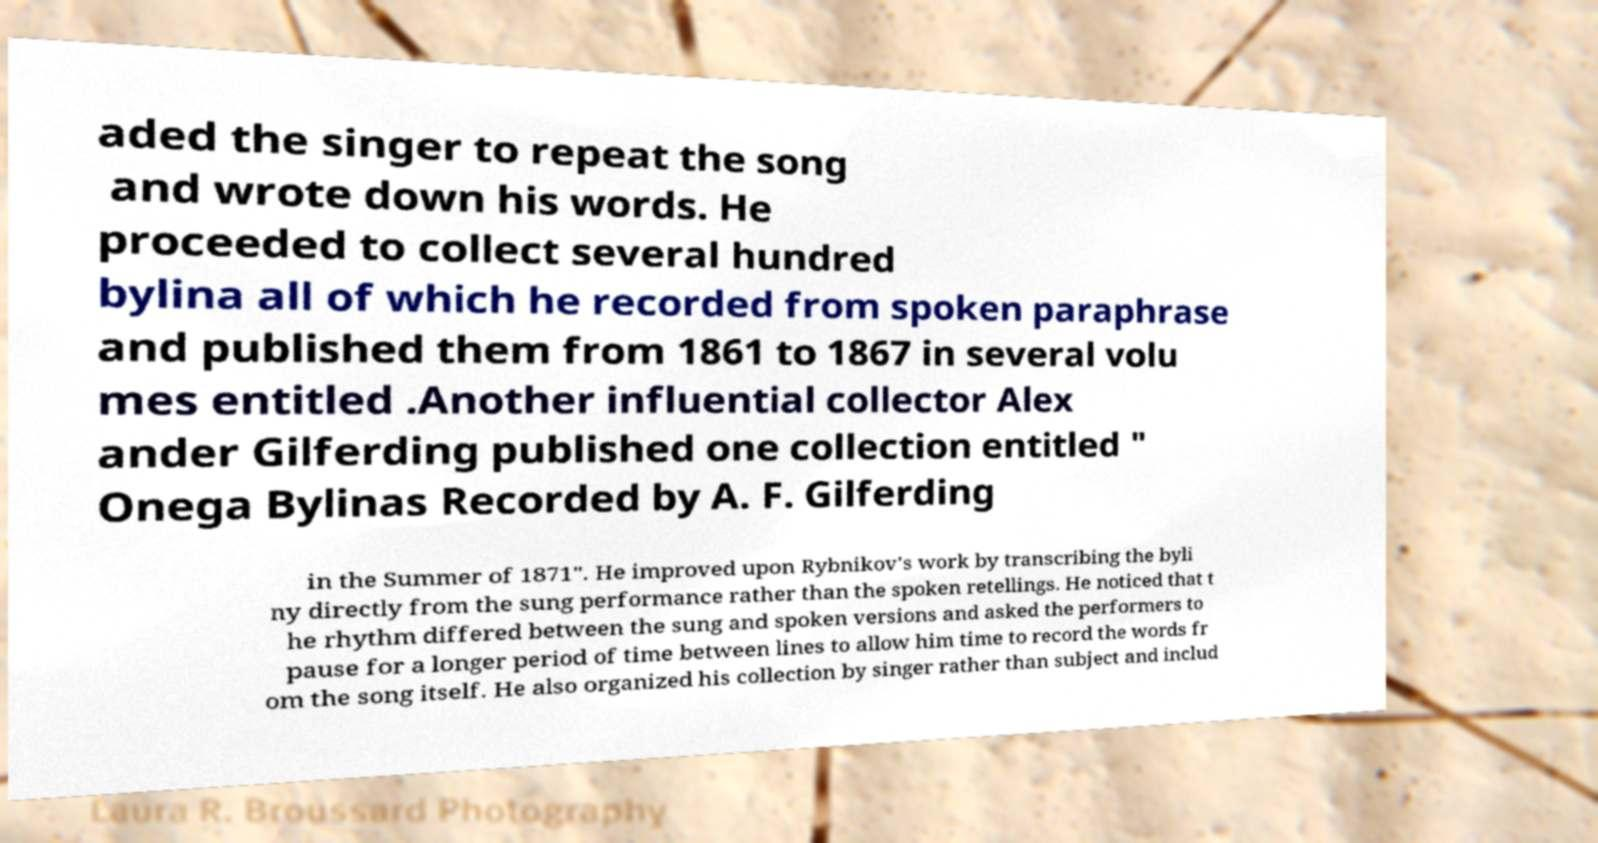There's text embedded in this image that I need extracted. Can you transcribe it verbatim? aded the singer to repeat the song and wrote down his words. He proceeded to collect several hundred bylina all of which he recorded from spoken paraphrase and published them from 1861 to 1867 in several volu mes entitled .Another influential collector Alex ander Gilferding published one collection entitled " Onega Bylinas Recorded by A. F. Gilferding in the Summer of 1871". He improved upon Rybnikov's work by transcribing the byli ny directly from the sung performance rather than the spoken retellings. He noticed that t he rhythm differed between the sung and spoken versions and asked the performers to pause for a longer period of time between lines to allow him time to record the words fr om the song itself. He also organized his collection by singer rather than subject and includ 